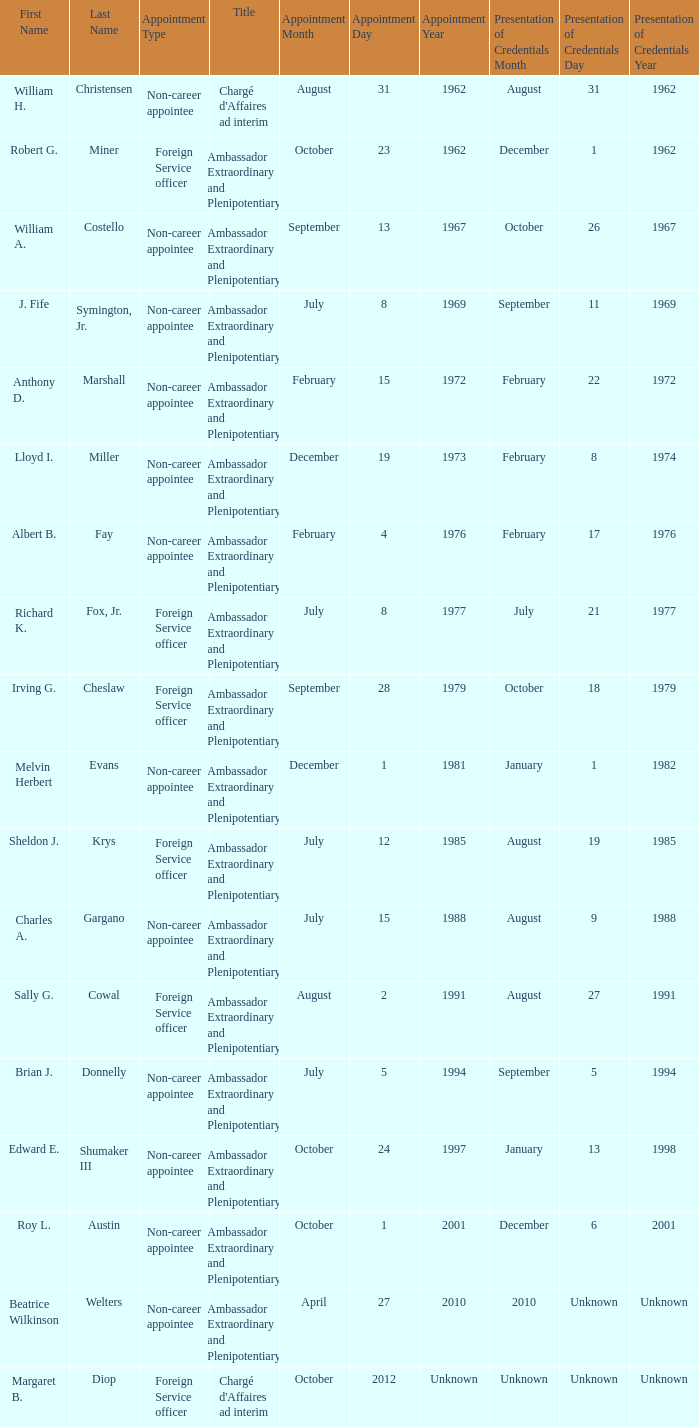When was William A. Costello appointed? September 13, 1967. Can you parse all the data within this table? {'header': ['First Name', 'Last Name', 'Appointment Type', 'Title', 'Appointment Month', 'Appointment Day', 'Appointment Year', 'Presentation of Credentials Month', 'Presentation of Credentials Day', 'Presentation of Credentials Year'], 'rows': [['William H.', 'Christensen', 'Non-career appointee', "Chargé d'Affaires ad interim", 'August', '31', '1962', 'August', '31', '1962'], ['Robert G.', 'Miner', 'Foreign Service officer', 'Ambassador Extraordinary and Plenipotentiary', 'October', '23', '1962', 'December', '1', '1962'], ['William A.', 'Costello', 'Non-career appointee', 'Ambassador Extraordinary and Plenipotentiary', 'September', '13', '1967', 'October', '26', '1967'], ['J. Fife', 'Symington, Jr.', 'Non-career appointee', 'Ambassador Extraordinary and Plenipotentiary', 'July', '8', '1969', 'September', '11', '1969'], ['Anthony D.', 'Marshall', 'Non-career appointee', 'Ambassador Extraordinary and Plenipotentiary', 'February', '15', '1972', 'February', '22', '1972'], ['Lloyd I.', 'Miller', 'Non-career appointee', 'Ambassador Extraordinary and Plenipotentiary', 'December', '19', '1973', 'February', '8', '1974'], ['Albert B.', 'Fay', 'Non-career appointee', 'Ambassador Extraordinary and Plenipotentiary', 'February', '4', '1976', 'February', '17', '1976'], ['Richard K.', 'Fox, Jr.', 'Foreign Service officer', 'Ambassador Extraordinary and Plenipotentiary', 'July', '8', '1977', 'July', '21', '1977'], ['Irving G.', 'Cheslaw', 'Foreign Service officer', 'Ambassador Extraordinary and Plenipotentiary', 'September', '28', '1979', 'October', '18', '1979'], ['Melvin Herbert', 'Evans', 'Non-career appointee', 'Ambassador Extraordinary and Plenipotentiary', 'December', '1', '1981', 'January', '1', '1982'], ['Sheldon J.', 'Krys', 'Foreign Service officer', 'Ambassador Extraordinary and Plenipotentiary', 'July', '12', '1985', 'August', '19', '1985'], ['Charles A.', 'Gargano', 'Non-career appointee', 'Ambassador Extraordinary and Plenipotentiary', 'July', '15', '1988', 'August', '9', '1988'], ['Sally G.', 'Cowal', 'Foreign Service officer', 'Ambassador Extraordinary and Plenipotentiary', 'August', '2', '1991', 'August', '27', '1991'], ['Brian J.', 'Donnelly', 'Non-career appointee', 'Ambassador Extraordinary and Plenipotentiary', 'July', '5', '1994', 'September', '5', '1994'], ['Edward E.', 'Shumaker III', 'Non-career appointee', 'Ambassador Extraordinary and Plenipotentiary', 'October', '24', '1997', 'January', '13', '1998'], ['Roy L.', 'Austin', 'Non-career appointee', 'Ambassador Extraordinary and Plenipotentiary', 'October', '1', '2001', 'December', '6', '2001'], ['Beatrice Wilkinson', 'Welters', 'Non-career appointee', 'Ambassador Extraordinary and Plenipotentiary', 'April', '27', '2010', '2010', 'Unknown', 'Unknown'], ['Margaret B.', 'Diop', 'Foreign Service officer', "Chargé d'Affaires ad interim", 'October', '2012', 'Unknown', 'Unknown', 'Unknown', 'Unknown']]} 